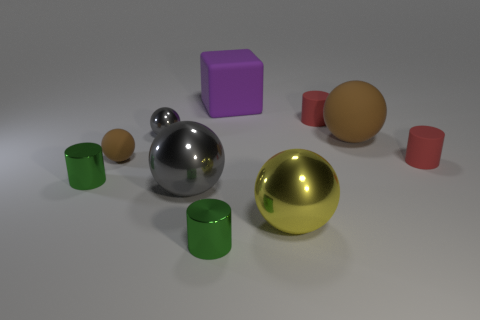Subtract all tiny gray metallic balls. How many balls are left? 4 Subtract all cylinders. How many objects are left? 6 Subtract all yellow spheres. How many spheres are left? 4 Subtract all yellow cylinders. Subtract all yellow balls. How many cylinders are left? 4 Subtract all blue balls. How many green cylinders are left? 2 Subtract all large purple cubes. Subtract all tiny red matte cylinders. How many objects are left? 7 Add 4 brown matte spheres. How many brown matte spheres are left? 6 Add 8 yellow balls. How many yellow balls exist? 9 Subtract 0 cyan blocks. How many objects are left? 10 